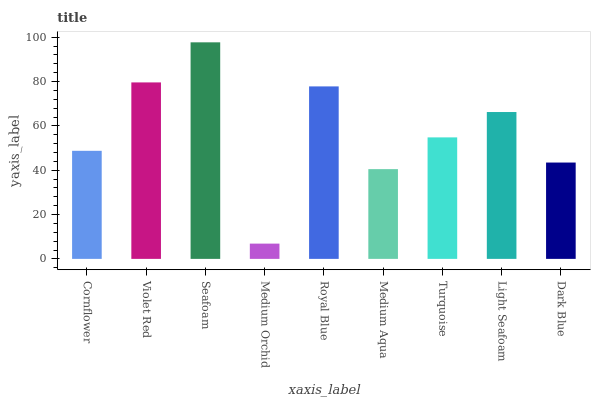Is Medium Orchid the minimum?
Answer yes or no. Yes. Is Seafoam the maximum?
Answer yes or no. Yes. Is Violet Red the minimum?
Answer yes or no. No. Is Violet Red the maximum?
Answer yes or no. No. Is Violet Red greater than Cornflower?
Answer yes or no. Yes. Is Cornflower less than Violet Red?
Answer yes or no. Yes. Is Cornflower greater than Violet Red?
Answer yes or no. No. Is Violet Red less than Cornflower?
Answer yes or no. No. Is Turquoise the high median?
Answer yes or no. Yes. Is Turquoise the low median?
Answer yes or no. Yes. Is Medium Orchid the high median?
Answer yes or no. No. Is Violet Red the low median?
Answer yes or no. No. 